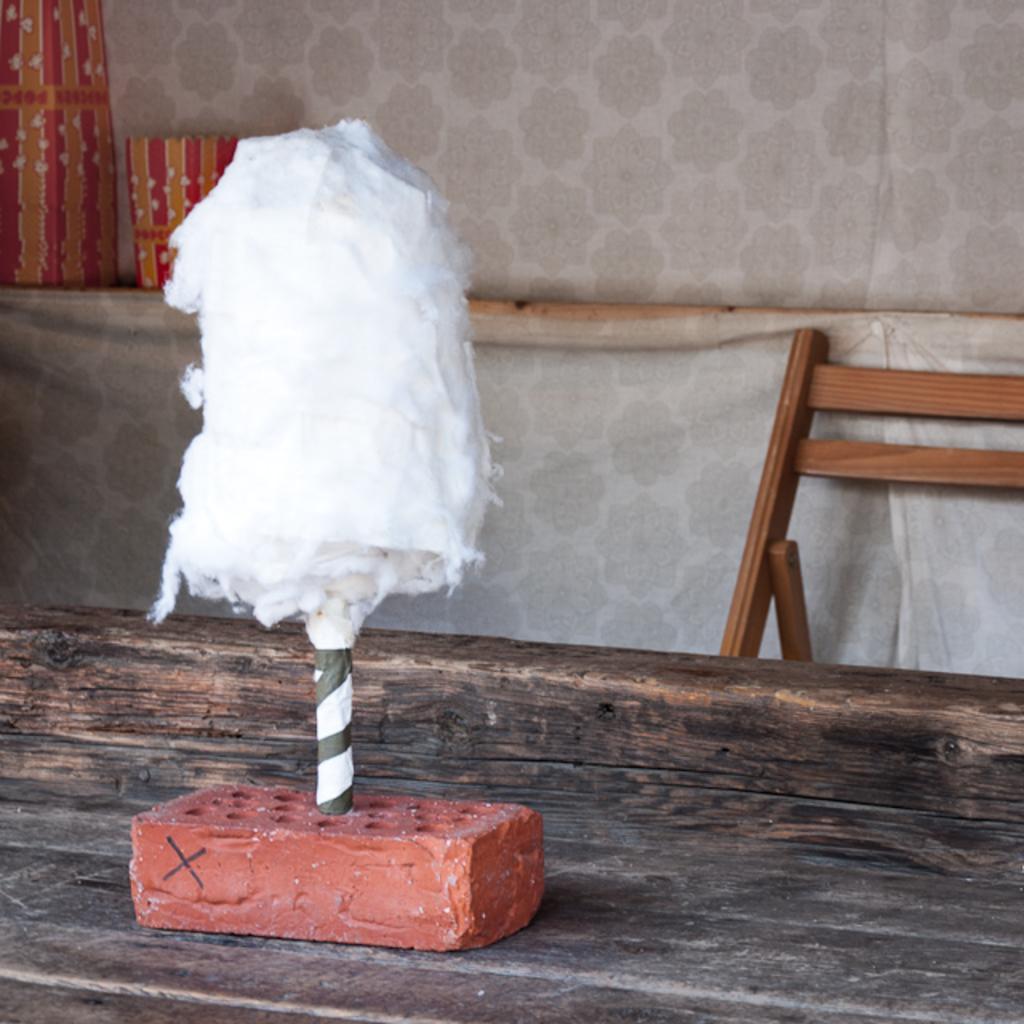In one or two sentences, can you explain what this image depicts? In this image, we can see a pole with cotton is inserted in the brick and in the background, there is chair and we can see a wall. At the bottom, there is table. 